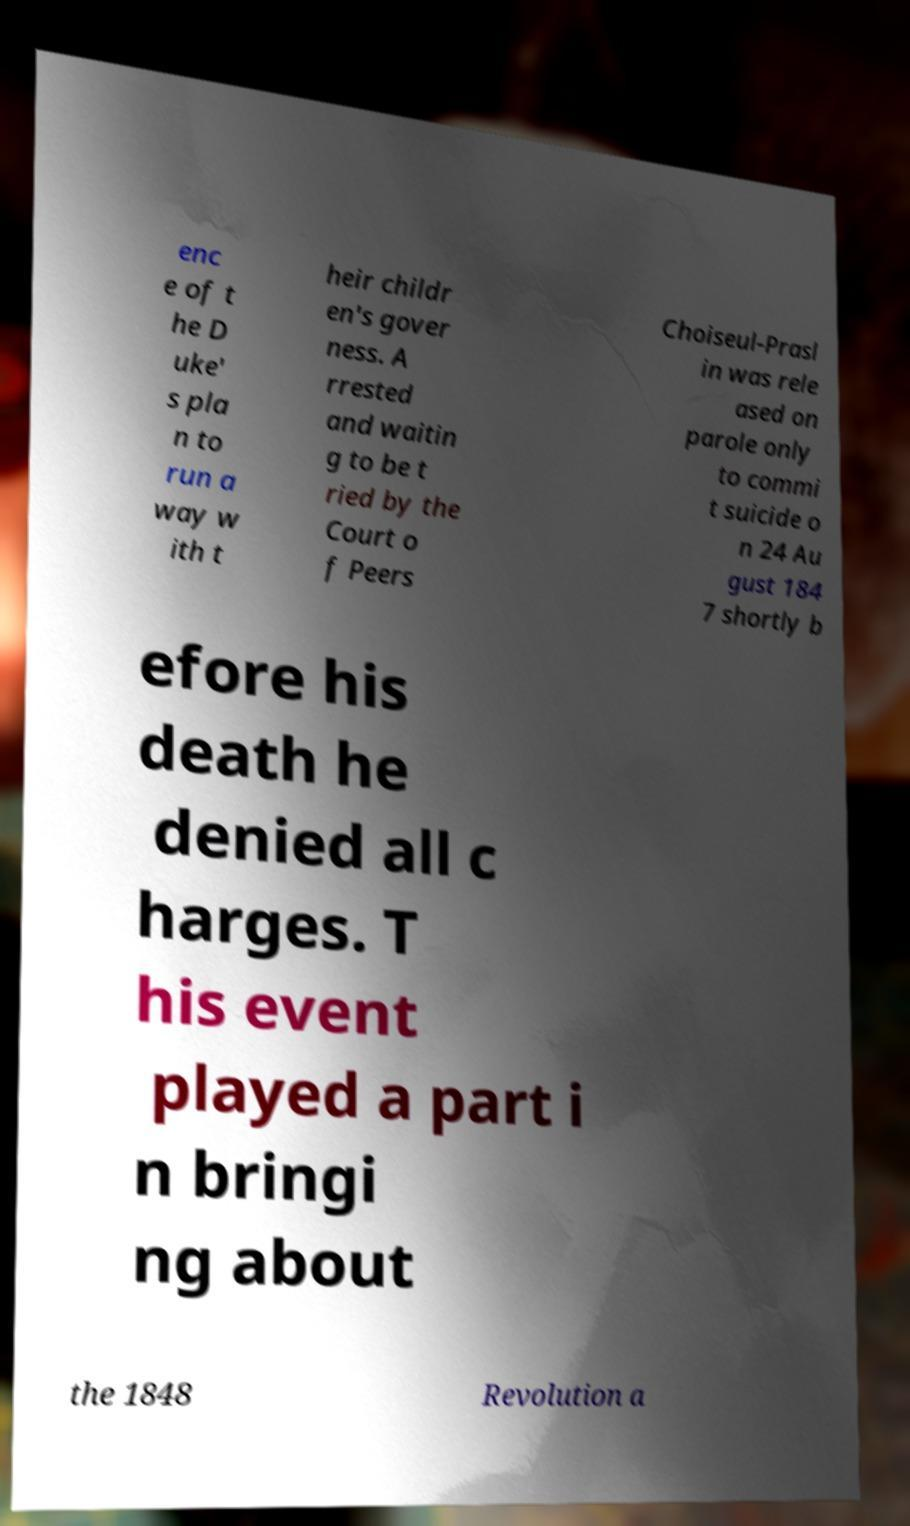Can you accurately transcribe the text from the provided image for me? enc e of t he D uke' s pla n to run a way w ith t heir childr en's gover ness. A rrested and waitin g to be t ried by the Court o f Peers Choiseul-Prasl in was rele ased on parole only to commi t suicide o n 24 Au gust 184 7 shortly b efore his death he denied all c harges. T his event played a part i n bringi ng about the 1848 Revolution a 